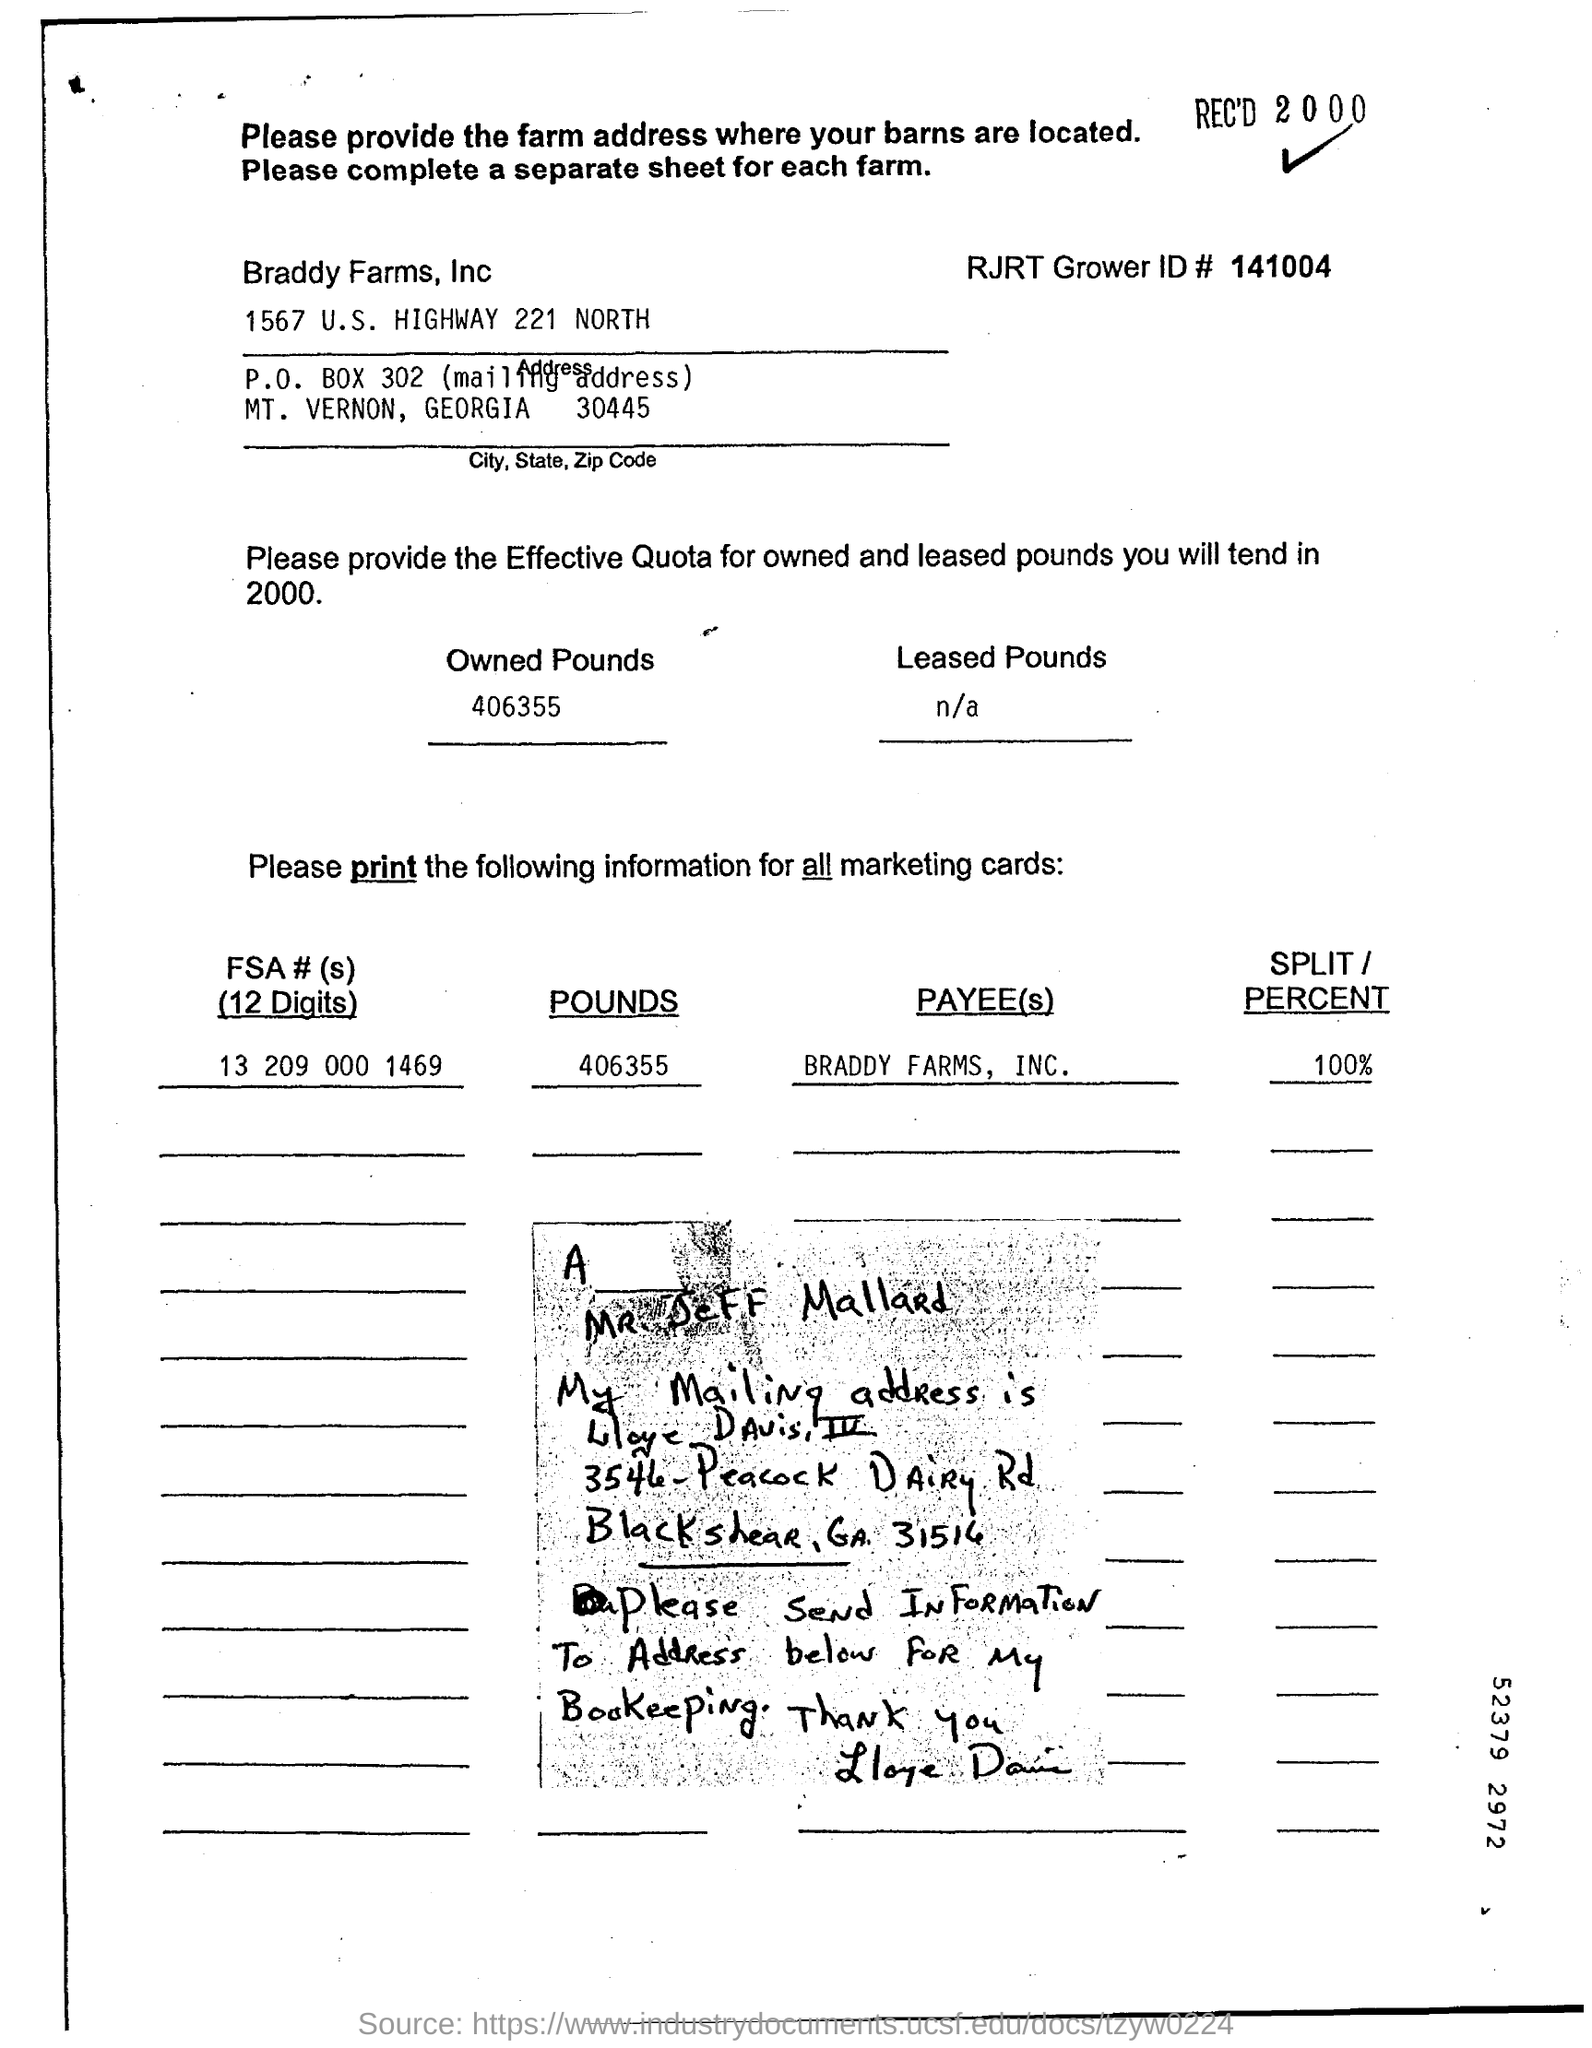Identify some key points in this picture. The FSA number is 13 209 000 1469. The RJRT Grower ID number is 141004. . 